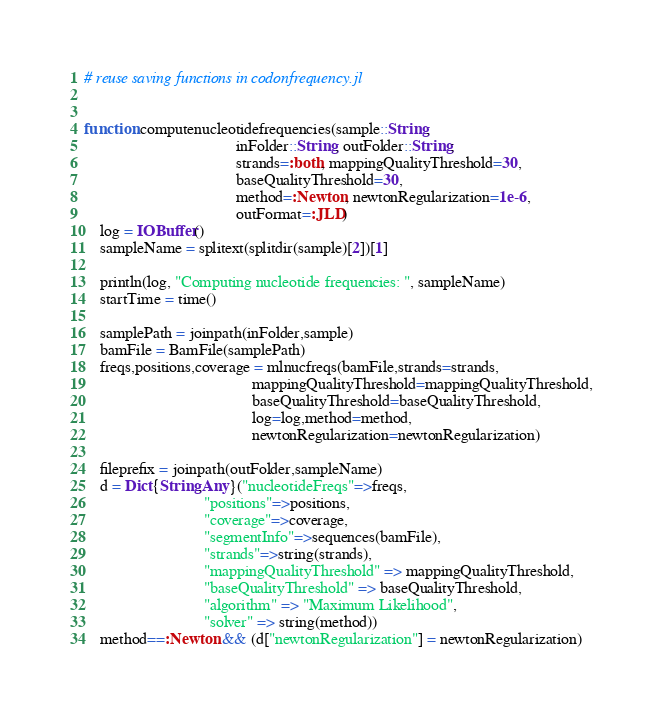Convert code to text. <code><loc_0><loc_0><loc_500><loc_500><_Julia_>

# reuse saving functions in codonfrequency.jl


function computenucleotidefrequencies(sample::String, 
                                      inFolder::String, outFolder::String; 
                                      strands=:both, mappingQualityThreshold=30, 
                                      baseQualityThreshold=30,
                                      method=:Newton, newtonRegularization=1e-6,
                                      outFormat=:JLD)
	log = IOBuffer()
	sampleName = splitext(splitdir(sample)[2])[1]

	println(log, "Computing nucleotide frequencies: ", sampleName)
	startTime = time()

	samplePath = joinpath(inFolder,sample)
	bamFile = BamFile(samplePath)
	freqs,positions,coverage = mlnucfreqs(bamFile,strands=strands,
	                                      mappingQualityThreshold=mappingQualityThreshold,
	                                      baseQualityThreshold=baseQualityThreshold,
	                                      log=log,method=method,
	                                      newtonRegularization=newtonRegularization)

	fileprefix = joinpath(outFolder,sampleName)
	d = Dict{String,Any}("nucleotideFreqs"=>freqs,
	                          "positions"=>positions,
	                          "coverage"=>coverage,
	                          "segmentInfo"=>sequences(bamFile),
	                          "strands"=>string(strands),
	                          "mappingQualityThreshold" => mappingQualityThreshold,
	                          "baseQualityThreshold" => baseQualityThreshold,
	                          "algorithm" => "Maximum Likelihood",
	                          "solver" => string(method))
	method==:Newton && (d["newtonRegularization"] = newtonRegularization)

</code> 